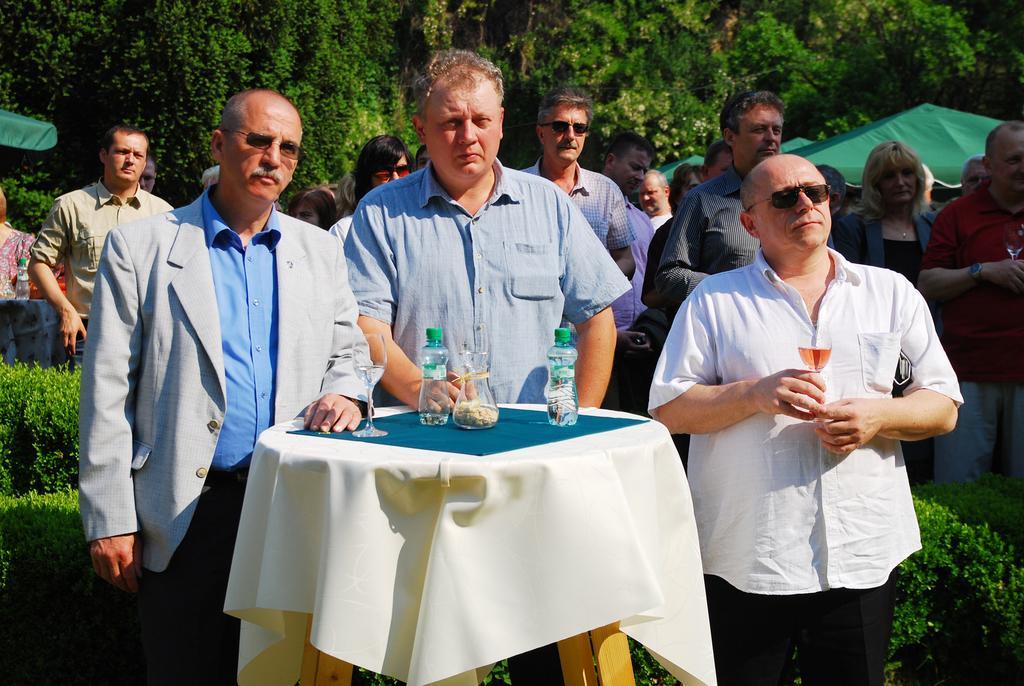Describe this image in one or two sentences. This image is taken in outdoors. There are few people in this image. In the right side of the image a man is standing holding a glass of wine in his hand. In the middle of the image two man are standing, behind a table and on the top of the table there is a table cloth, napkin, a glass with wine and two bottles on it. At the background there are many trees and plants and few people were standing under a tent. 